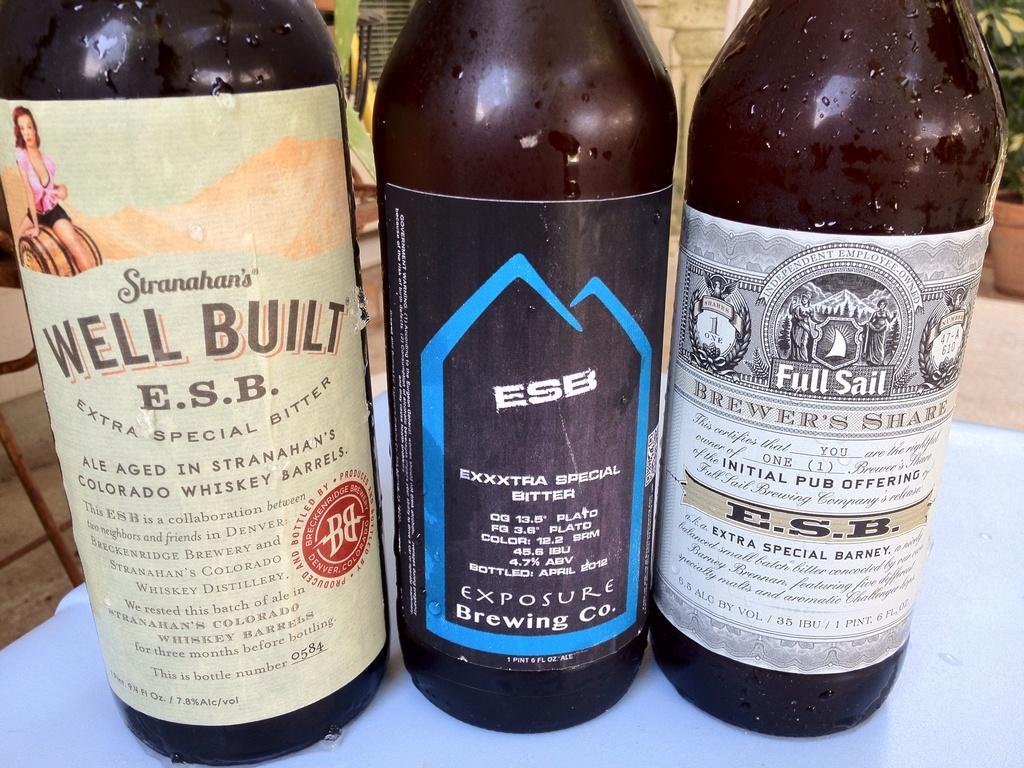What three letter company makes these drinks?
Offer a very short reply. Esb. What is the name of the brewing company of the middle bottle?
Offer a terse response. Exposure. 